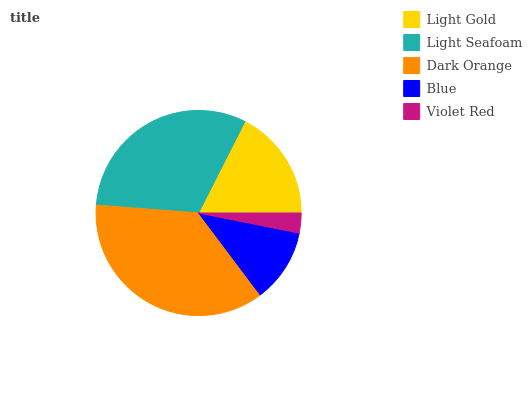Is Violet Red the minimum?
Answer yes or no. Yes. Is Dark Orange the maximum?
Answer yes or no. Yes. Is Light Seafoam the minimum?
Answer yes or no. No. Is Light Seafoam the maximum?
Answer yes or no. No. Is Light Seafoam greater than Light Gold?
Answer yes or no. Yes. Is Light Gold less than Light Seafoam?
Answer yes or no. Yes. Is Light Gold greater than Light Seafoam?
Answer yes or no. No. Is Light Seafoam less than Light Gold?
Answer yes or no. No. Is Light Gold the high median?
Answer yes or no. Yes. Is Light Gold the low median?
Answer yes or no. Yes. Is Blue the high median?
Answer yes or no. No. Is Light Seafoam the low median?
Answer yes or no. No. 